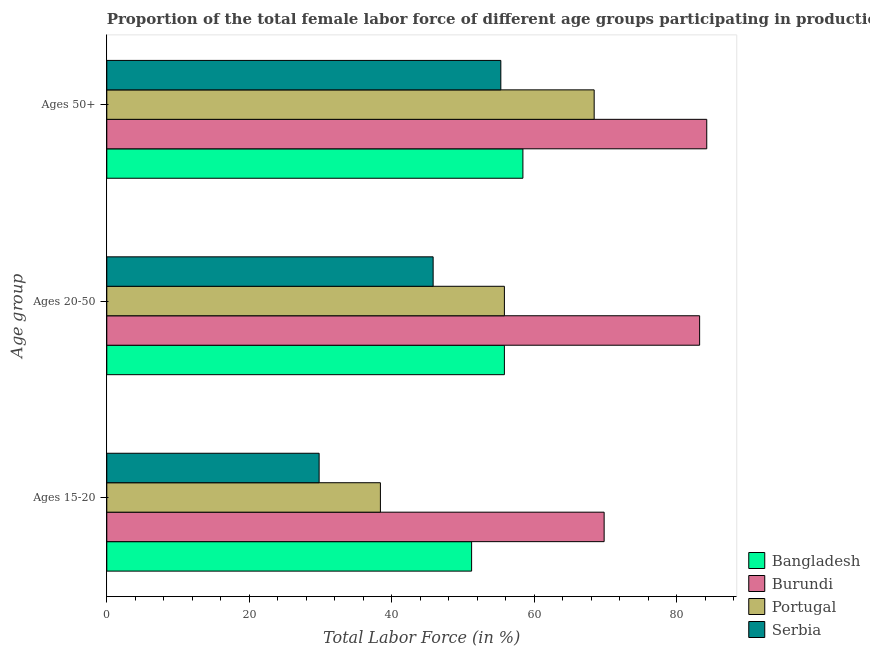How many groups of bars are there?
Make the answer very short. 3. What is the label of the 3rd group of bars from the top?
Offer a terse response. Ages 15-20. What is the percentage of female labor force within the age group 20-50 in Burundi?
Offer a very short reply. 83.2. Across all countries, what is the maximum percentage of female labor force above age 50?
Offer a very short reply. 84.2. Across all countries, what is the minimum percentage of female labor force within the age group 20-50?
Your answer should be very brief. 45.8. In which country was the percentage of female labor force above age 50 maximum?
Make the answer very short. Burundi. In which country was the percentage of female labor force within the age group 15-20 minimum?
Offer a very short reply. Serbia. What is the total percentage of female labor force above age 50 in the graph?
Provide a short and direct response. 266.3. What is the difference between the percentage of female labor force within the age group 20-50 in Portugal and that in Serbia?
Provide a succinct answer. 10. What is the difference between the percentage of female labor force within the age group 15-20 in Portugal and the percentage of female labor force above age 50 in Burundi?
Your response must be concise. -45.8. What is the average percentage of female labor force within the age group 20-50 per country?
Make the answer very short. 60.15. What is the difference between the percentage of female labor force above age 50 and percentage of female labor force within the age group 15-20 in Serbia?
Keep it short and to the point. 25.5. In how many countries, is the percentage of female labor force within the age group 20-50 greater than 60 %?
Your answer should be compact. 1. What is the ratio of the percentage of female labor force above age 50 in Serbia to that in Bangladesh?
Provide a short and direct response. 0.95. Is the difference between the percentage of female labor force within the age group 20-50 in Serbia and Burundi greater than the difference between the percentage of female labor force above age 50 in Serbia and Burundi?
Keep it short and to the point. No. What is the difference between the highest and the second highest percentage of female labor force within the age group 20-50?
Your response must be concise. 27.4. What is the difference between the highest and the lowest percentage of female labor force above age 50?
Ensure brevity in your answer.  28.9. Is the sum of the percentage of female labor force within the age group 20-50 in Burundi and Serbia greater than the maximum percentage of female labor force above age 50 across all countries?
Keep it short and to the point. Yes. What does the 3rd bar from the top in Ages 15-20 represents?
Your response must be concise. Burundi. What does the 2nd bar from the bottom in Ages 50+ represents?
Offer a terse response. Burundi. How many bars are there?
Your response must be concise. 12. Are all the bars in the graph horizontal?
Provide a short and direct response. Yes. How many countries are there in the graph?
Make the answer very short. 4. Are the values on the major ticks of X-axis written in scientific E-notation?
Your response must be concise. No. Does the graph contain grids?
Your answer should be compact. No. How many legend labels are there?
Offer a very short reply. 4. How are the legend labels stacked?
Offer a terse response. Vertical. What is the title of the graph?
Your answer should be compact. Proportion of the total female labor force of different age groups participating in production in 2006. Does "Jordan" appear as one of the legend labels in the graph?
Keep it short and to the point. No. What is the label or title of the X-axis?
Your answer should be very brief. Total Labor Force (in %). What is the label or title of the Y-axis?
Ensure brevity in your answer.  Age group. What is the Total Labor Force (in %) of Bangladesh in Ages 15-20?
Keep it short and to the point. 51.2. What is the Total Labor Force (in %) in Burundi in Ages 15-20?
Offer a very short reply. 69.8. What is the Total Labor Force (in %) of Portugal in Ages 15-20?
Give a very brief answer. 38.4. What is the Total Labor Force (in %) in Serbia in Ages 15-20?
Give a very brief answer. 29.8. What is the Total Labor Force (in %) of Bangladesh in Ages 20-50?
Offer a very short reply. 55.8. What is the Total Labor Force (in %) of Burundi in Ages 20-50?
Make the answer very short. 83.2. What is the Total Labor Force (in %) of Portugal in Ages 20-50?
Ensure brevity in your answer.  55.8. What is the Total Labor Force (in %) in Serbia in Ages 20-50?
Give a very brief answer. 45.8. What is the Total Labor Force (in %) in Bangladesh in Ages 50+?
Your response must be concise. 58.4. What is the Total Labor Force (in %) in Burundi in Ages 50+?
Provide a succinct answer. 84.2. What is the Total Labor Force (in %) in Portugal in Ages 50+?
Make the answer very short. 68.4. What is the Total Labor Force (in %) of Serbia in Ages 50+?
Provide a short and direct response. 55.3. Across all Age group, what is the maximum Total Labor Force (in %) in Bangladesh?
Ensure brevity in your answer.  58.4. Across all Age group, what is the maximum Total Labor Force (in %) in Burundi?
Ensure brevity in your answer.  84.2. Across all Age group, what is the maximum Total Labor Force (in %) of Portugal?
Make the answer very short. 68.4. Across all Age group, what is the maximum Total Labor Force (in %) of Serbia?
Your response must be concise. 55.3. Across all Age group, what is the minimum Total Labor Force (in %) of Bangladesh?
Your response must be concise. 51.2. Across all Age group, what is the minimum Total Labor Force (in %) in Burundi?
Your answer should be very brief. 69.8. Across all Age group, what is the minimum Total Labor Force (in %) in Portugal?
Your response must be concise. 38.4. Across all Age group, what is the minimum Total Labor Force (in %) of Serbia?
Ensure brevity in your answer.  29.8. What is the total Total Labor Force (in %) in Bangladesh in the graph?
Offer a terse response. 165.4. What is the total Total Labor Force (in %) of Burundi in the graph?
Your answer should be compact. 237.2. What is the total Total Labor Force (in %) in Portugal in the graph?
Give a very brief answer. 162.6. What is the total Total Labor Force (in %) in Serbia in the graph?
Ensure brevity in your answer.  130.9. What is the difference between the Total Labor Force (in %) of Burundi in Ages 15-20 and that in Ages 20-50?
Your answer should be very brief. -13.4. What is the difference between the Total Labor Force (in %) in Portugal in Ages 15-20 and that in Ages 20-50?
Make the answer very short. -17.4. What is the difference between the Total Labor Force (in %) in Serbia in Ages 15-20 and that in Ages 20-50?
Make the answer very short. -16. What is the difference between the Total Labor Force (in %) of Burundi in Ages 15-20 and that in Ages 50+?
Your response must be concise. -14.4. What is the difference between the Total Labor Force (in %) in Portugal in Ages 15-20 and that in Ages 50+?
Your response must be concise. -30. What is the difference between the Total Labor Force (in %) of Serbia in Ages 15-20 and that in Ages 50+?
Offer a terse response. -25.5. What is the difference between the Total Labor Force (in %) of Portugal in Ages 20-50 and that in Ages 50+?
Your response must be concise. -12.6. What is the difference between the Total Labor Force (in %) of Bangladesh in Ages 15-20 and the Total Labor Force (in %) of Burundi in Ages 20-50?
Ensure brevity in your answer.  -32. What is the difference between the Total Labor Force (in %) in Bangladesh in Ages 15-20 and the Total Labor Force (in %) in Portugal in Ages 20-50?
Your answer should be very brief. -4.6. What is the difference between the Total Labor Force (in %) in Bangladesh in Ages 15-20 and the Total Labor Force (in %) in Serbia in Ages 20-50?
Offer a very short reply. 5.4. What is the difference between the Total Labor Force (in %) of Burundi in Ages 15-20 and the Total Labor Force (in %) of Portugal in Ages 20-50?
Offer a very short reply. 14. What is the difference between the Total Labor Force (in %) of Bangladesh in Ages 15-20 and the Total Labor Force (in %) of Burundi in Ages 50+?
Your answer should be very brief. -33. What is the difference between the Total Labor Force (in %) of Bangladesh in Ages 15-20 and the Total Labor Force (in %) of Portugal in Ages 50+?
Your answer should be very brief. -17.2. What is the difference between the Total Labor Force (in %) in Burundi in Ages 15-20 and the Total Labor Force (in %) in Portugal in Ages 50+?
Make the answer very short. 1.4. What is the difference between the Total Labor Force (in %) of Burundi in Ages 15-20 and the Total Labor Force (in %) of Serbia in Ages 50+?
Keep it short and to the point. 14.5. What is the difference between the Total Labor Force (in %) in Portugal in Ages 15-20 and the Total Labor Force (in %) in Serbia in Ages 50+?
Offer a terse response. -16.9. What is the difference between the Total Labor Force (in %) of Bangladesh in Ages 20-50 and the Total Labor Force (in %) of Burundi in Ages 50+?
Ensure brevity in your answer.  -28.4. What is the difference between the Total Labor Force (in %) in Burundi in Ages 20-50 and the Total Labor Force (in %) in Portugal in Ages 50+?
Your answer should be very brief. 14.8. What is the difference between the Total Labor Force (in %) of Burundi in Ages 20-50 and the Total Labor Force (in %) of Serbia in Ages 50+?
Your answer should be very brief. 27.9. What is the average Total Labor Force (in %) in Bangladesh per Age group?
Your response must be concise. 55.13. What is the average Total Labor Force (in %) of Burundi per Age group?
Offer a terse response. 79.07. What is the average Total Labor Force (in %) in Portugal per Age group?
Offer a terse response. 54.2. What is the average Total Labor Force (in %) in Serbia per Age group?
Your response must be concise. 43.63. What is the difference between the Total Labor Force (in %) in Bangladesh and Total Labor Force (in %) in Burundi in Ages 15-20?
Your response must be concise. -18.6. What is the difference between the Total Labor Force (in %) of Bangladesh and Total Labor Force (in %) of Portugal in Ages 15-20?
Offer a terse response. 12.8. What is the difference between the Total Labor Force (in %) in Bangladesh and Total Labor Force (in %) in Serbia in Ages 15-20?
Your response must be concise. 21.4. What is the difference between the Total Labor Force (in %) of Burundi and Total Labor Force (in %) of Portugal in Ages 15-20?
Your answer should be compact. 31.4. What is the difference between the Total Labor Force (in %) of Burundi and Total Labor Force (in %) of Serbia in Ages 15-20?
Make the answer very short. 40. What is the difference between the Total Labor Force (in %) of Bangladesh and Total Labor Force (in %) of Burundi in Ages 20-50?
Your response must be concise. -27.4. What is the difference between the Total Labor Force (in %) of Bangladesh and Total Labor Force (in %) of Serbia in Ages 20-50?
Keep it short and to the point. 10. What is the difference between the Total Labor Force (in %) of Burundi and Total Labor Force (in %) of Portugal in Ages 20-50?
Give a very brief answer. 27.4. What is the difference between the Total Labor Force (in %) of Burundi and Total Labor Force (in %) of Serbia in Ages 20-50?
Make the answer very short. 37.4. What is the difference between the Total Labor Force (in %) of Portugal and Total Labor Force (in %) of Serbia in Ages 20-50?
Provide a succinct answer. 10. What is the difference between the Total Labor Force (in %) in Bangladesh and Total Labor Force (in %) in Burundi in Ages 50+?
Ensure brevity in your answer.  -25.8. What is the difference between the Total Labor Force (in %) in Bangladesh and Total Labor Force (in %) in Portugal in Ages 50+?
Offer a terse response. -10. What is the difference between the Total Labor Force (in %) of Bangladesh and Total Labor Force (in %) of Serbia in Ages 50+?
Your response must be concise. 3.1. What is the difference between the Total Labor Force (in %) in Burundi and Total Labor Force (in %) in Portugal in Ages 50+?
Your answer should be very brief. 15.8. What is the difference between the Total Labor Force (in %) in Burundi and Total Labor Force (in %) in Serbia in Ages 50+?
Your response must be concise. 28.9. What is the difference between the Total Labor Force (in %) in Portugal and Total Labor Force (in %) in Serbia in Ages 50+?
Ensure brevity in your answer.  13.1. What is the ratio of the Total Labor Force (in %) in Bangladesh in Ages 15-20 to that in Ages 20-50?
Make the answer very short. 0.92. What is the ratio of the Total Labor Force (in %) in Burundi in Ages 15-20 to that in Ages 20-50?
Provide a succinct answer. 0.84. What is the ratio of the Total Labor Force (in %) in Portugal in Ages 15-20 to that in Ages 20-50?
Give a very brief answer. 0.69. What is the ratio of the Total Labor Force (in %) in Serbia in Ages 15-20 to that in Ages 20-50?
Provide a succinct answer. 0.65. What is the ratio of the Total Labor Force (in %) in Bangladesh in Ages 15-20 to that in Ages 50+?
Your response must be concise. 0.88. What is the ratio of the Total Labor Force (in %) in Burundi in Ages 15-20 to that in Ages 50+?
Make the answer very short. 0.83. What is the ratio of the Total Labor Force (in %) in Portugal in Ages 15-20 to that in Ages 50+?
Provide a succinct answer. 0.56. What is the ratio of the Total Labor Force (in %) of Serbia in Ages 15-20 to that in Ages 50+?
Your response must be concise. 0.54. What is the ratio of the Total Labor Force (in %) in Bangladesh in Ages 20-50 to that in Ages 50+?
Provide a short and direct response. 0.96. What is the ratio of the Total Labor Force (in %) in Portugal in Ages 20-50 to that in Ages 50+?
Offer a very short reply. 0.82. What is the ratio of the Total Labor Force (in %) of Serbia in Ages 20-50 to that in Ages 50+?
Provide a succinct answer. 0.83. What is the difference between the highest and the second highest Total Labor Force (in %) of Burundi?
Give a very brief answer. 1. What is the difference between the highest and the second highest Total Labor Force (in %) in Portugal?
Offer a very short reply. 12.6. What is the difference between the highest and the lowest Total Labor Force (in %) in Serbia?
Your answer should be very brief. 25.5. 